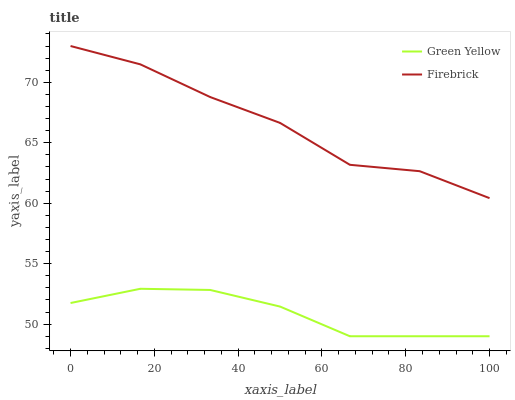Does Green Yellow have the maximum area under the curve?
Answer yes or no. No. Is Green Yellow the roughest?
Answer yes or no. No. Does Green Yellow have the highest value?
Answer yes or no. No. Is Green Yellow less than Firebrick?
Answer yes or no. Yes. Is Firebrick greater than Green Yellow?
Answer yes or no. Yes. Does Green Yellow intersect Firebrick?
Answer yes or no. No. 